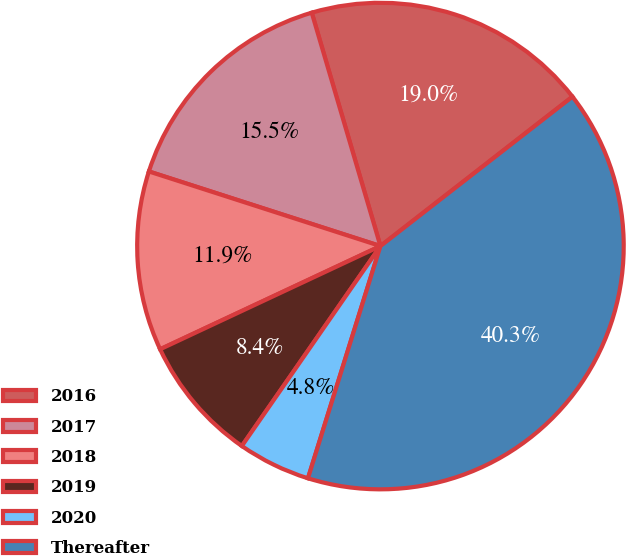Convert chart. <chart><loc_0><loc_0><loc_500><loc_500><pie_chart><fcel>2016<fcel>2017<fcel>2018<fcel>2019<fcel>2020<fcel>Thereafter<nl><fcel>19.03%<fcel>15.48%<fcel>11.93%<fcel>8.38%<fcel>4.83%<fcel>40.33%<nl></chart> 